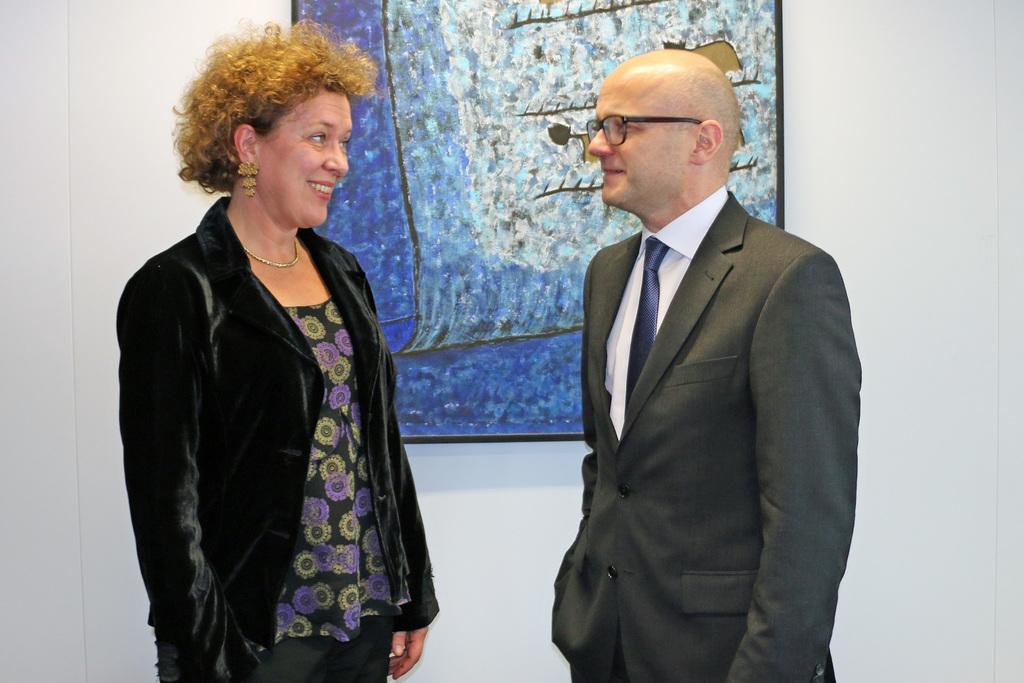Can you describe this image briefly? In this image I can see two person standing, the person at right is wearing black blazer, white shirt and blue color tie and the person at left is wearing black and purple color dress. Background I can see a frame attached to the wall and the wall is in white color. 